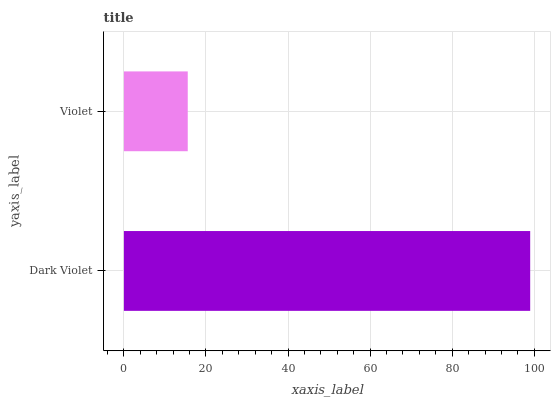Is Violet the minimum?
Answer yes or no. Yes. Is Dark Violet the maximum?
Answer yes or no. Yes. Is Violet the maximum?
Answer yes or no. No. Is Dark Violet greater than Violet?
Answer yes or no. Yes. Is Violet less than Dark Violet?
Answer yes or no. Yes. Is Violet greater than Dark Violet?
Answer yes or no. No. Is Dark Violet less than Violet?
Answer yes or no. No. Is Dark Violet the high median?
Answer yes or no. Yes. Is Violet the low median?
Answer yes or no. Yes. Is Violet the high median?
Answer yes or no. No. Is Dark Violet the low median?
Answer yes or no. No. 